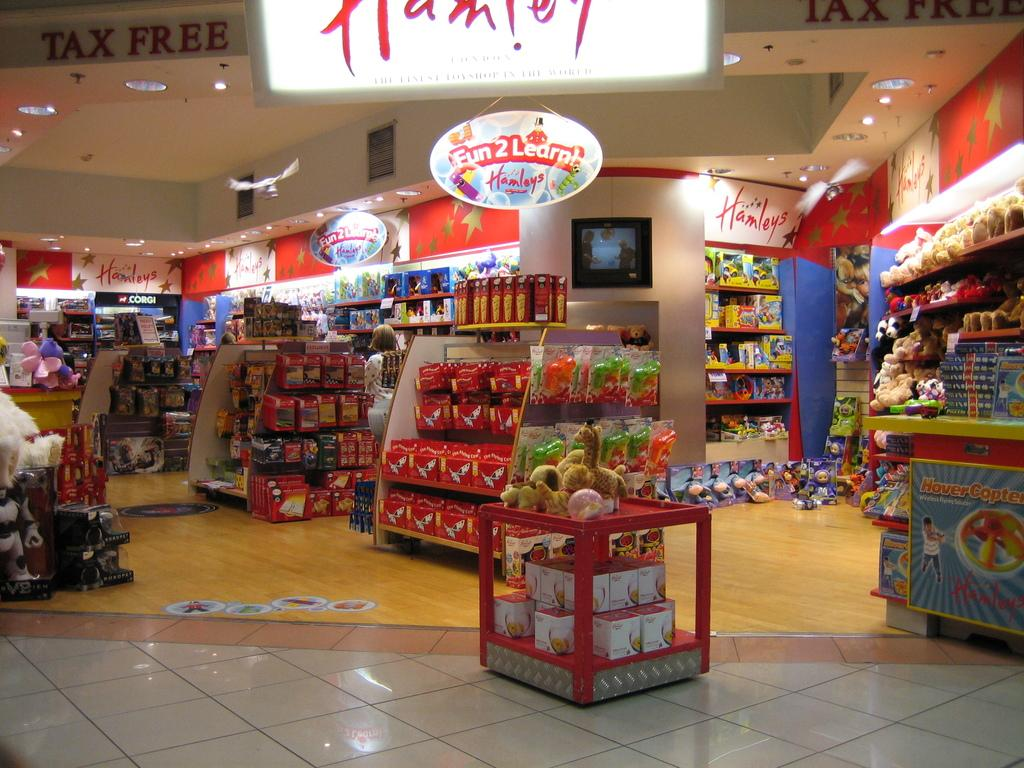Provide a one-sentence caption for the provided image. A sign is hanging from the ceiling of Hanley's stating Fun 2 Learn!. 